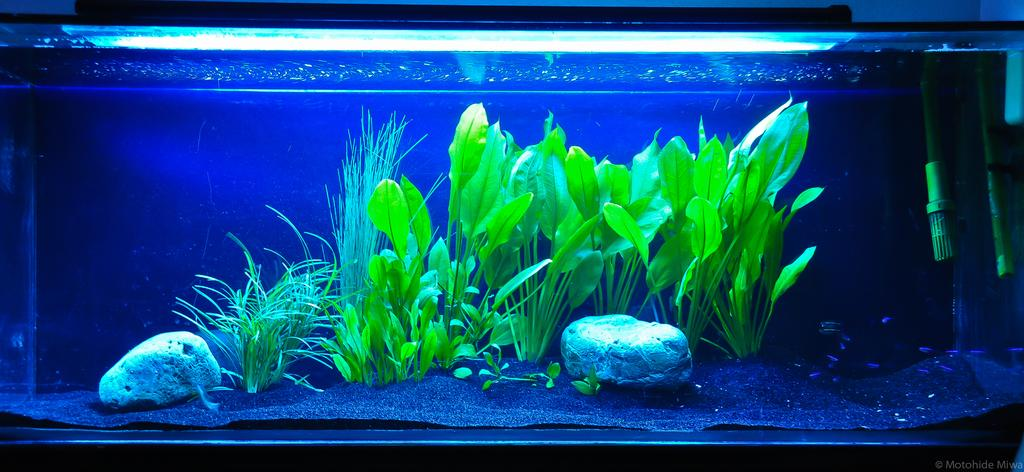What is the main object in the image? There is an aquarium in the image. What types of objects can be found inside the aquarium? The aquarium contains grass, plants, stones, and fish. Can you describe the contents of the aquarium in more detail? The aquarium contains grass, plants, and stones, as well as fish swimming among them. What type of pan is being used to cook the fish in the image? There is no pan or cooking activity present in the image; it features an aquarium with fish swimming among plants and stones. 